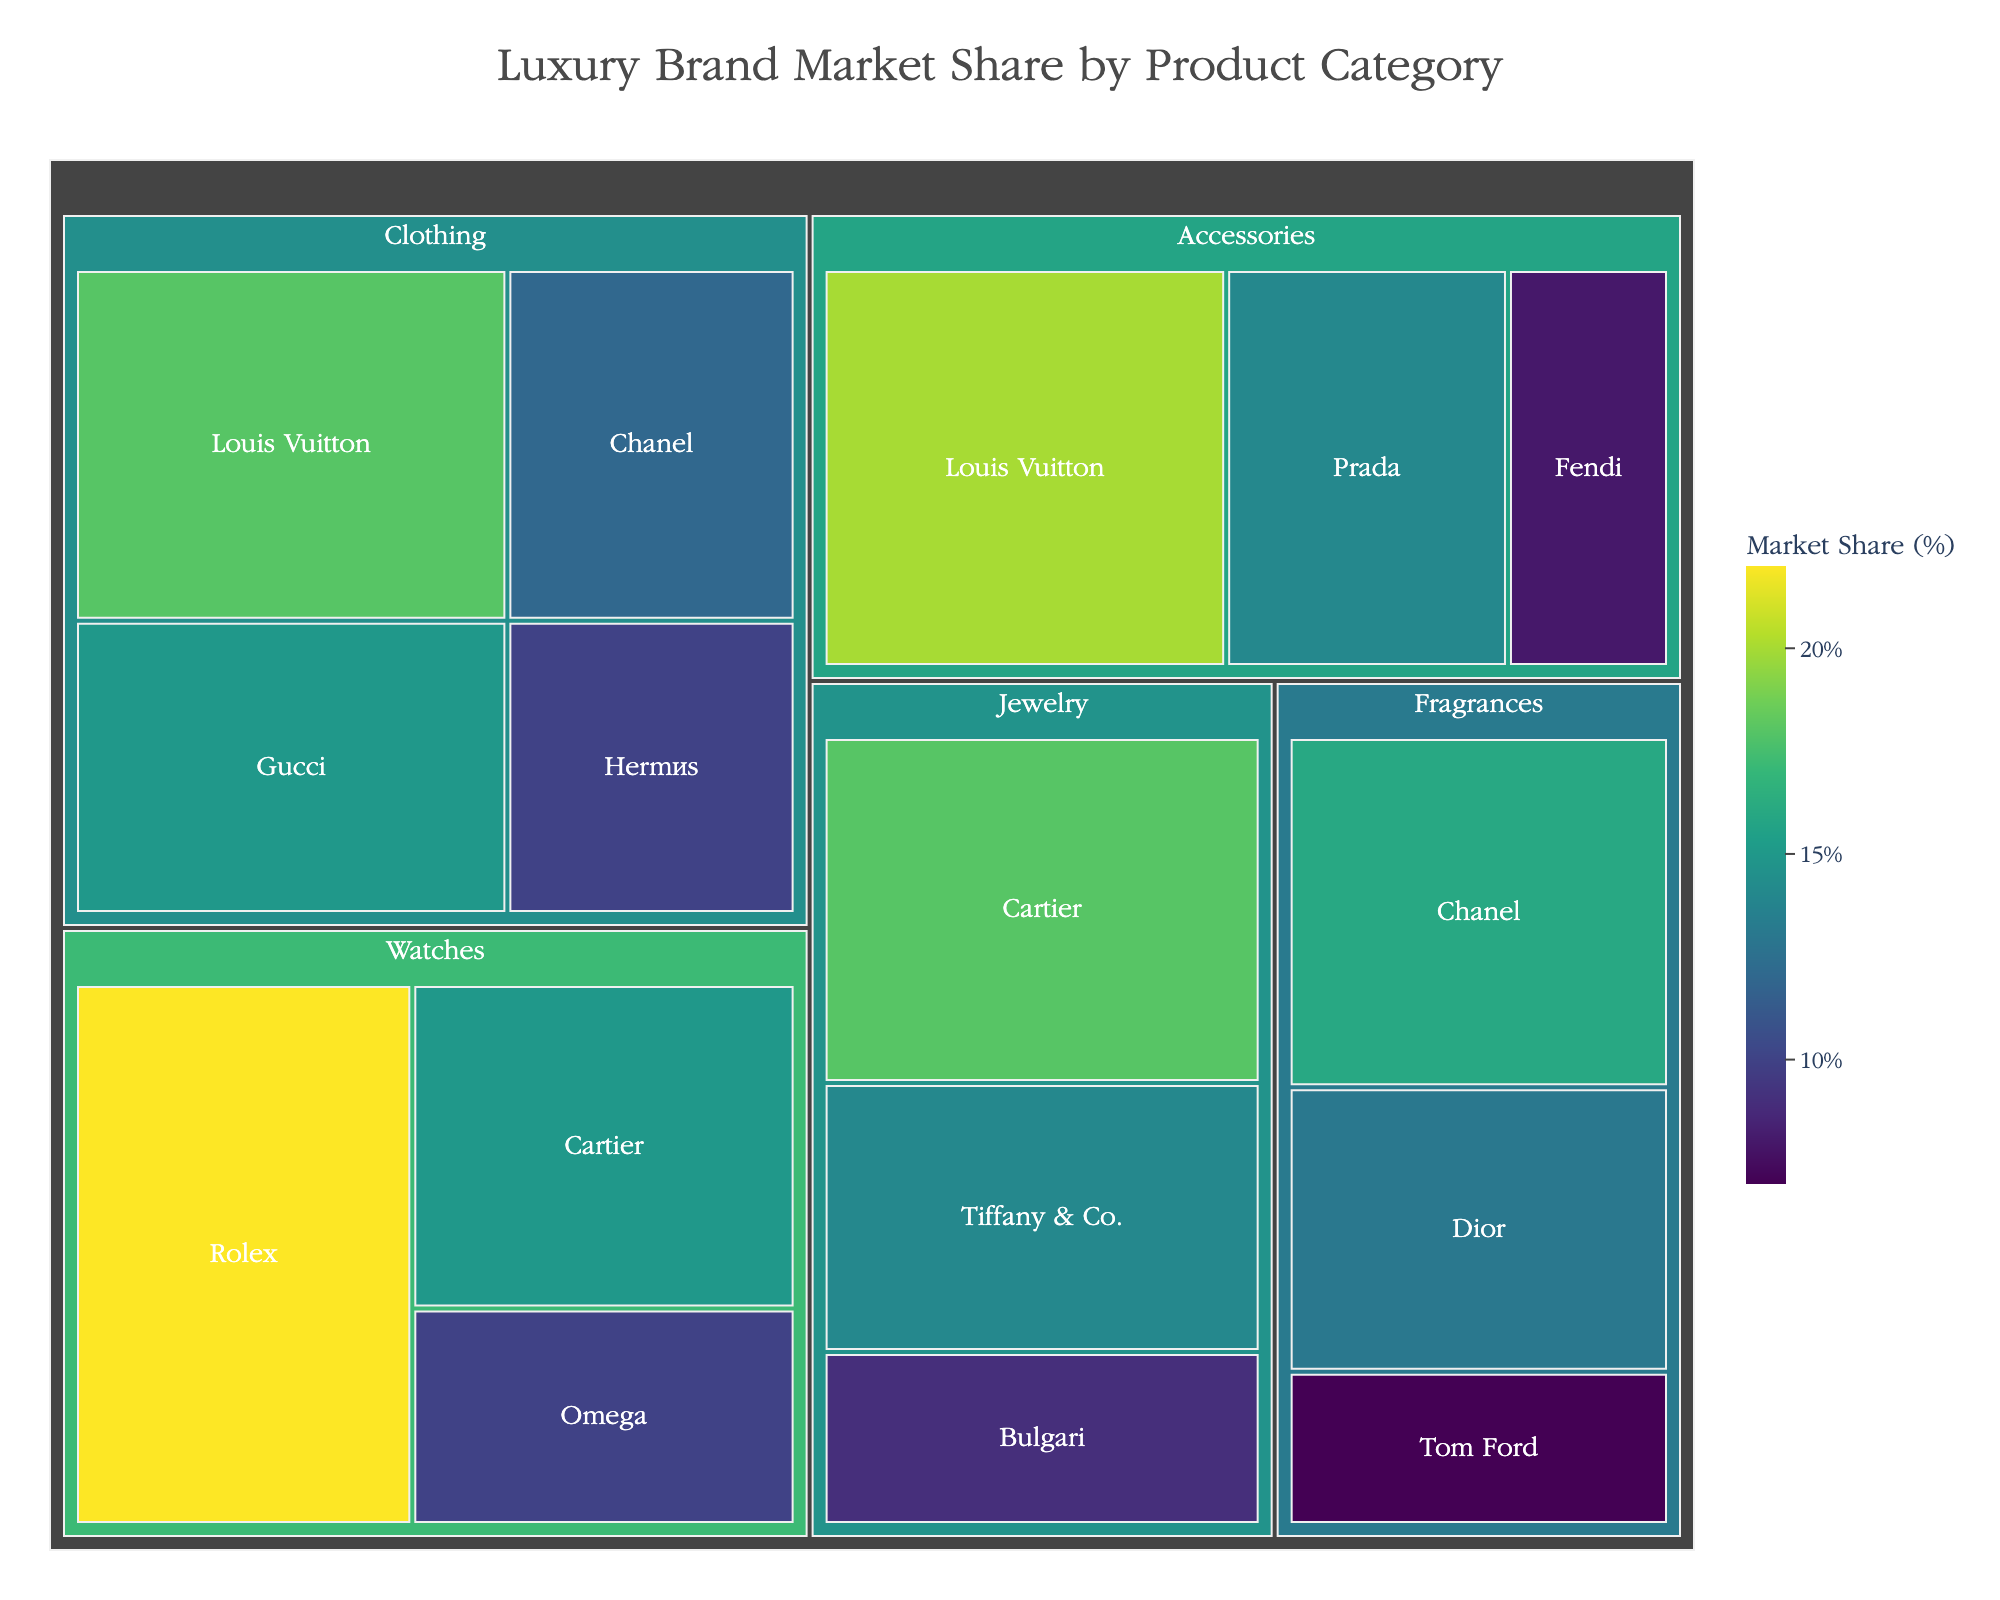Which brand has the highest market share in the accessories category? By looking at the treemap for the accessories category, we can see that Louis Vuitton has the largest block. This means it has the highest market share in this category.
Answer: Louis Vuitton What is the total market share of Louis Vuitton across all categories? To find the total market share of Louis Vuitton, we need to add up its market shares in Clothing and Accessories. For Clothing, it's 18%, and for Accessories, it's 20%. So, the total is 18% + 20% = 38%.
Answer: 38% Which category has the highest total market share? To determine the category with the highest total market share, we compare the areas of the largest blocks representing each category. Watches, led by Rolex, has the largest combined area.
Answer: Watches Which brand appears in the most number of categories? By examining each category, we can see that the brand Chanel appears in both Clothing and Fragrances categories. Since no other brand appears in more categories, Chanel is the answer.
Answer: Chanel How much greater is the combined market share of Chanel in Clothing and Fragrances compared to Tom Ford in Fragrances? Chanel's market share in Clothing is 12%, and in Fragrances, it is 16%. The combined market share is 12% + 16% = 28%. Tom Ford's market share in Fragrances is 7%. Therefore, the difference is 28% - 7% = 21%.
Answer: 21% Which brand has the smallest market share in the Watches category? In the Watches category, the smallest block corresponds to Omega. Therefore, Omega has the smallest market share.
Answer: Omega Compare the market share of Cartier between the Watches and Jewelry categories. Which category has the higher market share for Cartier? In the Watches category, Cartier has a market share of 15%. In the Jewelry category, Cartier has a market share of 18%. Therefore, Cartier has a higher market share in Jewelry.
Answer: Jewelry What is the average market share of brands in the Fragrances category? The market shares in the Fragrances category are 16% for Chanel, 13% for Dior, and 7% for Tom Ford. The average is calculated as (16% + 13% + 7%) / 3 = 36% / 3 = 12%.
Answer: 12% Which category has the smallest combined market share? By comparing the relative sizes of all categories in the treemap, Jewelry has the smallest blocks collectively, indicating it has the smallest combined market share.
Answer: Jewelry 